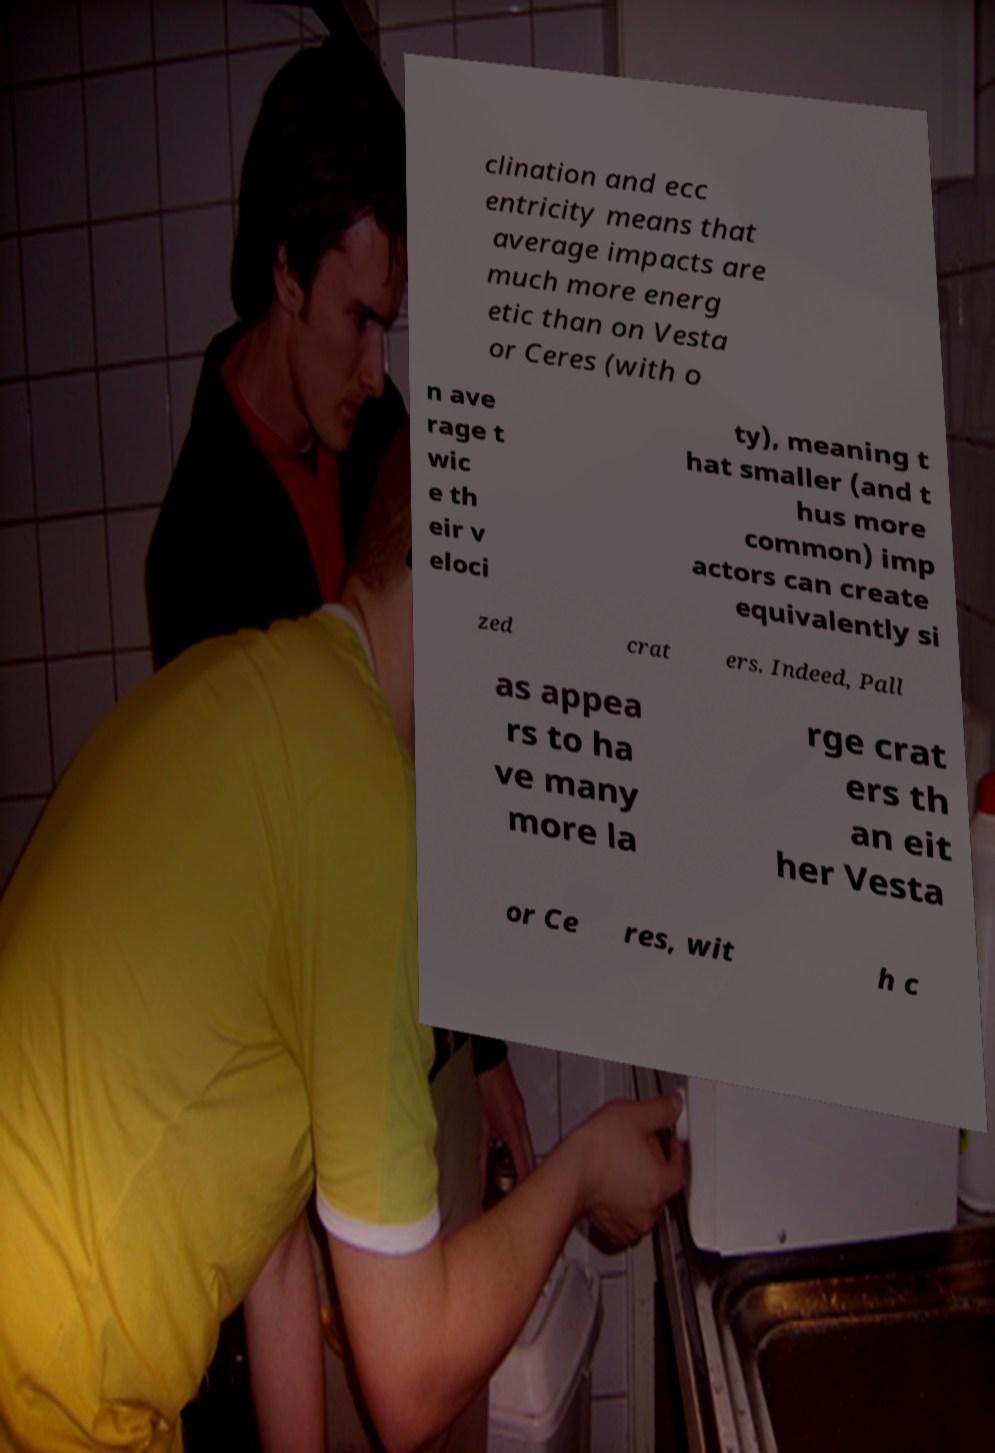For documentation purposes, I need the text within this image transcribed. Could you provide that? clination and ecc entricity means that average impacts are much more energ etic than on Vesta or Ceres (with o n ave rage t wic e th eir v eloci ty), meaning t hat smaller (and t hus more common) imp actors can create equivalently si zed crat ers. Indeed, Pall as appea rs to ha ve many more la rge crat ers th an eit her Vesta or Ce res, wit h c 